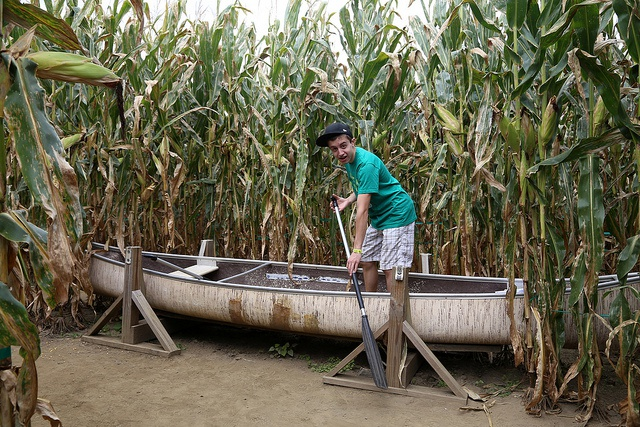Describe the objects in this image and their specific colors. I can see boat in gray, darkgray, black, and lightgray tones and people in gray, black, teal, and darkgray tones in this image. 